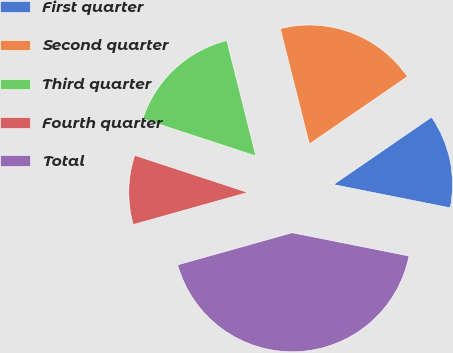<chart> <loc_0><loc_0><loc_500><loc_500><pie_chart><fcel>First quarter<fcel>Second quarter<fcel>Third quarter<fcel>Fourth quarter<fcel>Total<nl><fcel>12.72%<fcel>19.34%<fcel>16.03%<fcel>9.4%<fcel>42.52%<nl></chart> 